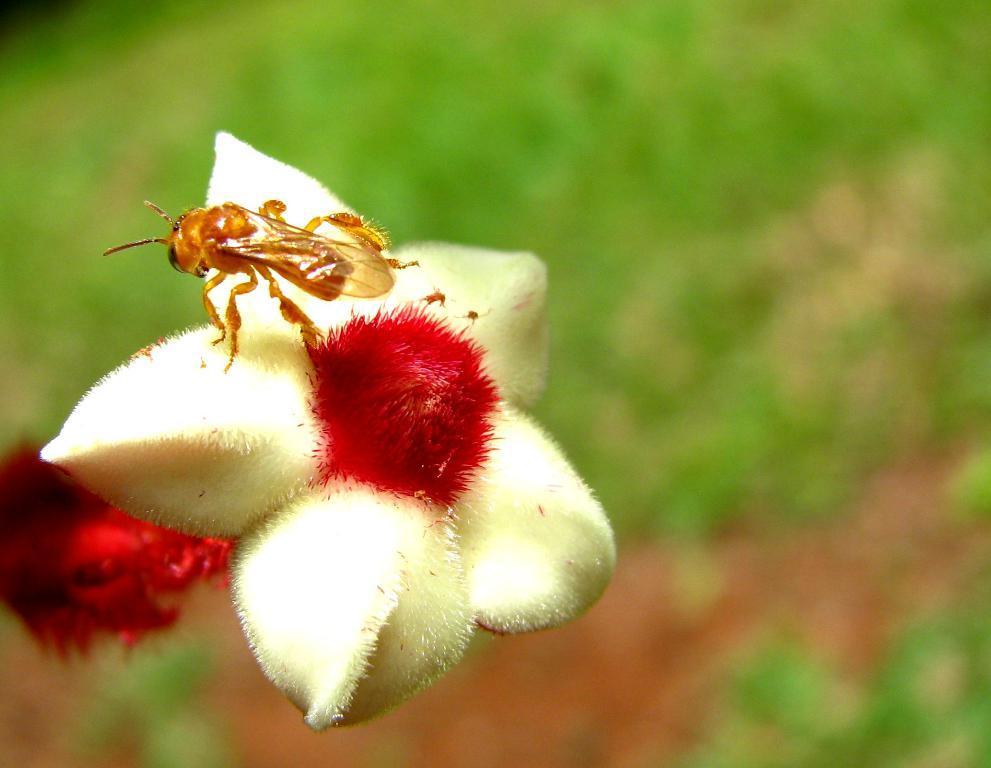Please provide a concise description of this image. In this image we can see a bug on the flower. 